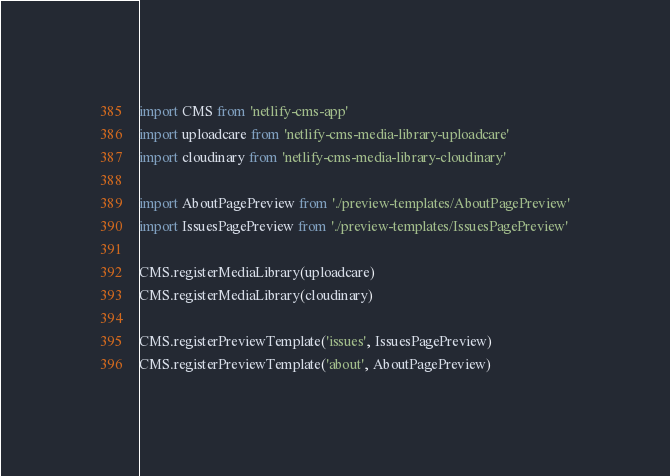Convert code to text. <code><loc_0><loc_0><loc_500><loc_500><_JavaScript_>import CMS from 'netlify-cms-app'
import uploadcare from 'netlify-cms-media-library-uploadcare'
import cloudinary from 'netlify-cms-media-library-cloudinary'

import AboutPagePreview from './preview-templates/AboutPagePreview'
import IssuesPagePreview from './preview-templates/IssuesPagePreview'

CMS.registerMediaLibrary(uploadcare)
CMS.registerMediaLibrary(cloudinary)

CMS.registerPreviewTemplate('issues', IssuesPagePreview)
CMS.registerPreviewTemplate('about', AboutPagePreview)
</code> 